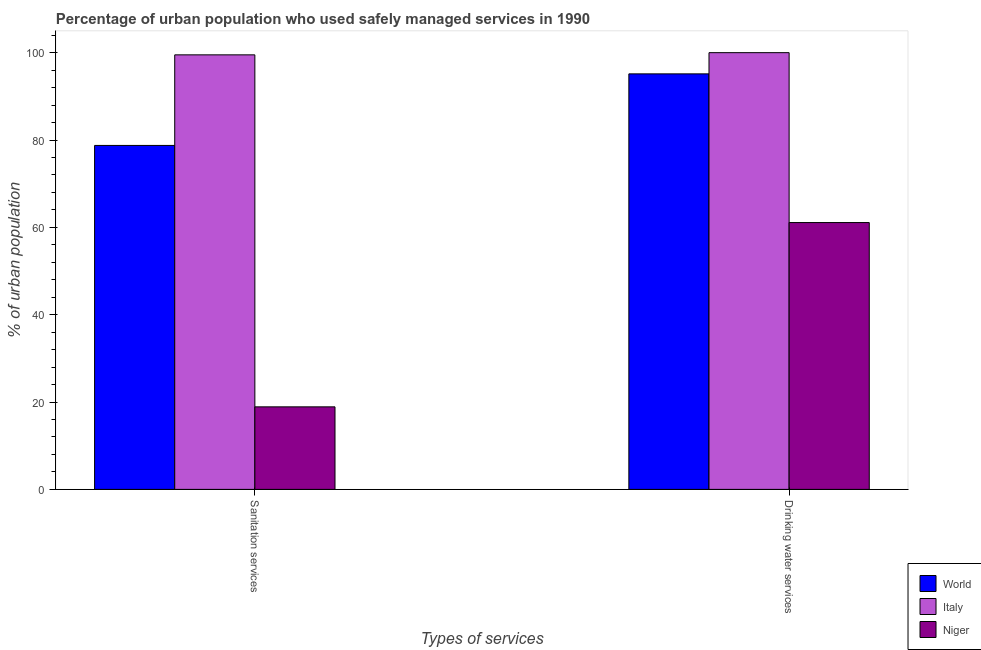How many different coloured bars are there?
Give a very brief answer. 3. How many groups of bars are there?
Give a very brief answer. 2. Are the number of bars on each tick of the X-axis equal?
Give a very brief answer. Yes. What is the label of the 2nd group of bars from the left?
Offer a terse response. Drinking water services. What is the percentage of urban population who used drinking water services in Italy?
Provide a succinct answer. 100. Across all countries, what is the maximum percentage of urban population who used drinking water services?
Provide a succinct answer. 100. Across all countries, what is the minimum percentage of urban population who used drinking water services?
Provide a short and direct response. 61.1. In which country was the percentage of urban population who used sanitation services minimum?
Offer a terse response. Niger. What is the total percentage of urban population who used sanitation services in the graph?
Your answer should be very brief. 197.16. What is the difference between the percentage of urban population who used sanitation services in Italy and that in Niger?
Offer a very short reply. 80.6. What is the difference between the percentage of urban population who used drinking water services in World and the percentage of urban population who used sanitation services in Niger?
Provide a short and direct response. 76.24. What is the average percentage of urban population who used sanitation services per country?
Give a very brief answer. 65.72. What is the difference between the percentage of urban population who used sanitation services and percentage of urban population who used drinking water services in Italy?
Offer a terse response. -0.5. What is the ratio of the percentage of urban population who used drinking water services in Italy to that in World?
Provide a short and direct response. 1.05. What does the 3rd bar from the right in Drinking water services represents?
Your response must be concise. World. What is the difference between two consecutive major ticks on the Y-axis?
Your answer should be very brief. 20. Does the graph contain any zero values?
Your response must be concise. No. How many legend labels are there?
Your response must be concise. 3. How are the legend labels stacked?
Give a very brief answer. Vertical. What is the title of the graph?
Give a very brief answer. Percentage of urban population who used safely managed services in 1990. What is the label or title of the X-axis?
Offer a terse response. Types of services. What is the label or title of the Y-axis?
Your response must be concise. % of urban population. What is the % of urban population in World in Sanitation services?
Give a very brief answer. 78.76. What is the % of urban population of Italy in Sanitation services?
Offer a very short reply. 99.5. What is the % of urban population of Niger in Sanitation services?
Your answer should be very brief. 18.9. What is the % of urban population of World in Drinking water services?
Offer a very short reply. 95.14. What is the % of urban population of Italy in Drinking water services?
Give a very brief answer. 100. What is the % of urban population in Niger in Drinking water services?
Offer a very short reply. 61.1. Across all Types of services, what is the maximum % of urban population of World?
Your answer should be compact. 95.14. Across all Types of services, what is the maximum % of urban population in Italy?
Your answer should be compact. 100. Across all Types of services, what is the maximum % of urban population of Niger?
Your answer should be very brief. 61.1. Across all Types of services, what is the minimum % of urban population in World?
Provide a succinct answer. 78.76. Across all Types of services, what is the minimum % of urban population in Italy?
Make the answer very short. 99.5. What is the total % of urban population in World in the graph?
Provide a succinct answer. 173.9. What is the total % of urban population in Italy in the graph?
Keep it short and to the point. 199.5. What is the total % of urban population in Niger in the graph?
Your answer should be very brief. 80. What is the difference between the % of urban population of World in Sanitation services and that in Drinking water services?
Your response must be concise. -16.39. What is the difference between the % of urban population of Italy in Sanitation services and that in Drinking water services?
Keep it short and to the point. -0.5. What is the difference between the % of urban population of Niger in Sanitation services and that in Drinking water services?
Your answer should be very brief. -42.2. What is the difference between the % of urban population in World in Sanitation services and the % of urban population in Italy in Drinking water services?
Provide a short and direct response. -21.24. What is the difference between the % of urban population of World in Sanitation services and the % of urban population of Niger in Drinking water services?
Ensure brevity in your answer.  17.66. What is the difference between the % of urban population of Italy in Sanitation services and the % of urban population of Niger in Drinking water services?
Your answer should be compact. 38.4. What is the average % of urban population of World per Types of services?
Make the answer very short. 86.95. What is the average % of urban population in Italy per Types of services?
Make the answer very short. 99.75. What is the difference between the % of urban population of World and % of urban population of Italy in Sanitation services?
Your response must be concise. -20.74. What is the difference between the % of urban population in World and % of urban population in Niger in Sanitation services?
Your response must be concise. 59.86. What is the difference between the % of urban population of Italy and % of urban population of Niger in Sanitation services?
Make the answer very short. 80.6. What is the difference between the % of urban population in World and % of urban population in Italy in Drinking water services?
Offer a terse response. -4.86. What is the difference between the % of urban population in World and % of urban population in Niger in Drinking water services?
Your answer should be compact. 34.04. What is the difference between the % of urban population of Italy and % of urban population of Niger in Drinking water services?
Offer a terse response. 38.9. What is the ratio of the % of urban population in World in Sanitation services to that in Drinking water services?
Provide a succinct answer. 0.83. What is the ratio of the % of urban population in Italy in Sanitation services to that in Drinking water services?
Ensure brevity in your answer.  0.99. What is the ratio of the % of urban population in Niger in Sanitation services to that in Drinking water services?
Your answer should be compact. 0.31. What is the difference between the highest and the second highest % of urban population in World?
Offer a terse response. 16.39. What is the difference between the highest and the second highest % of urban population of Italy?
Provide a short and direct response. 0.5. What is the difference between the highest and the second highest % of urban population of Niger?
Offer a very short reply. 42.2. What is the difference between the highest and the lowest % of urban population in World?
Provide a succinct answer. 16.39. What is the difference between the highest and the lowest % of urban population in Italy?
Give a very brief answer. 0.5. What is the difference between the highest and the lowest % of urban population in Niger?
Your answer should be compact. 42.2. 